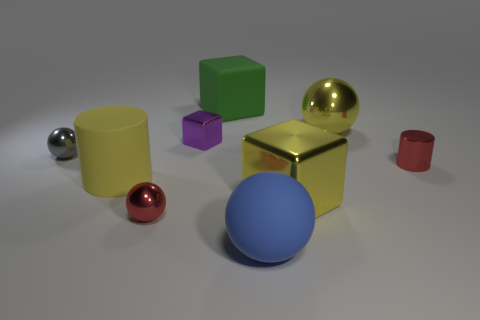Are there any yellow rubber objects that have the same shape as the green rubber thing? no 